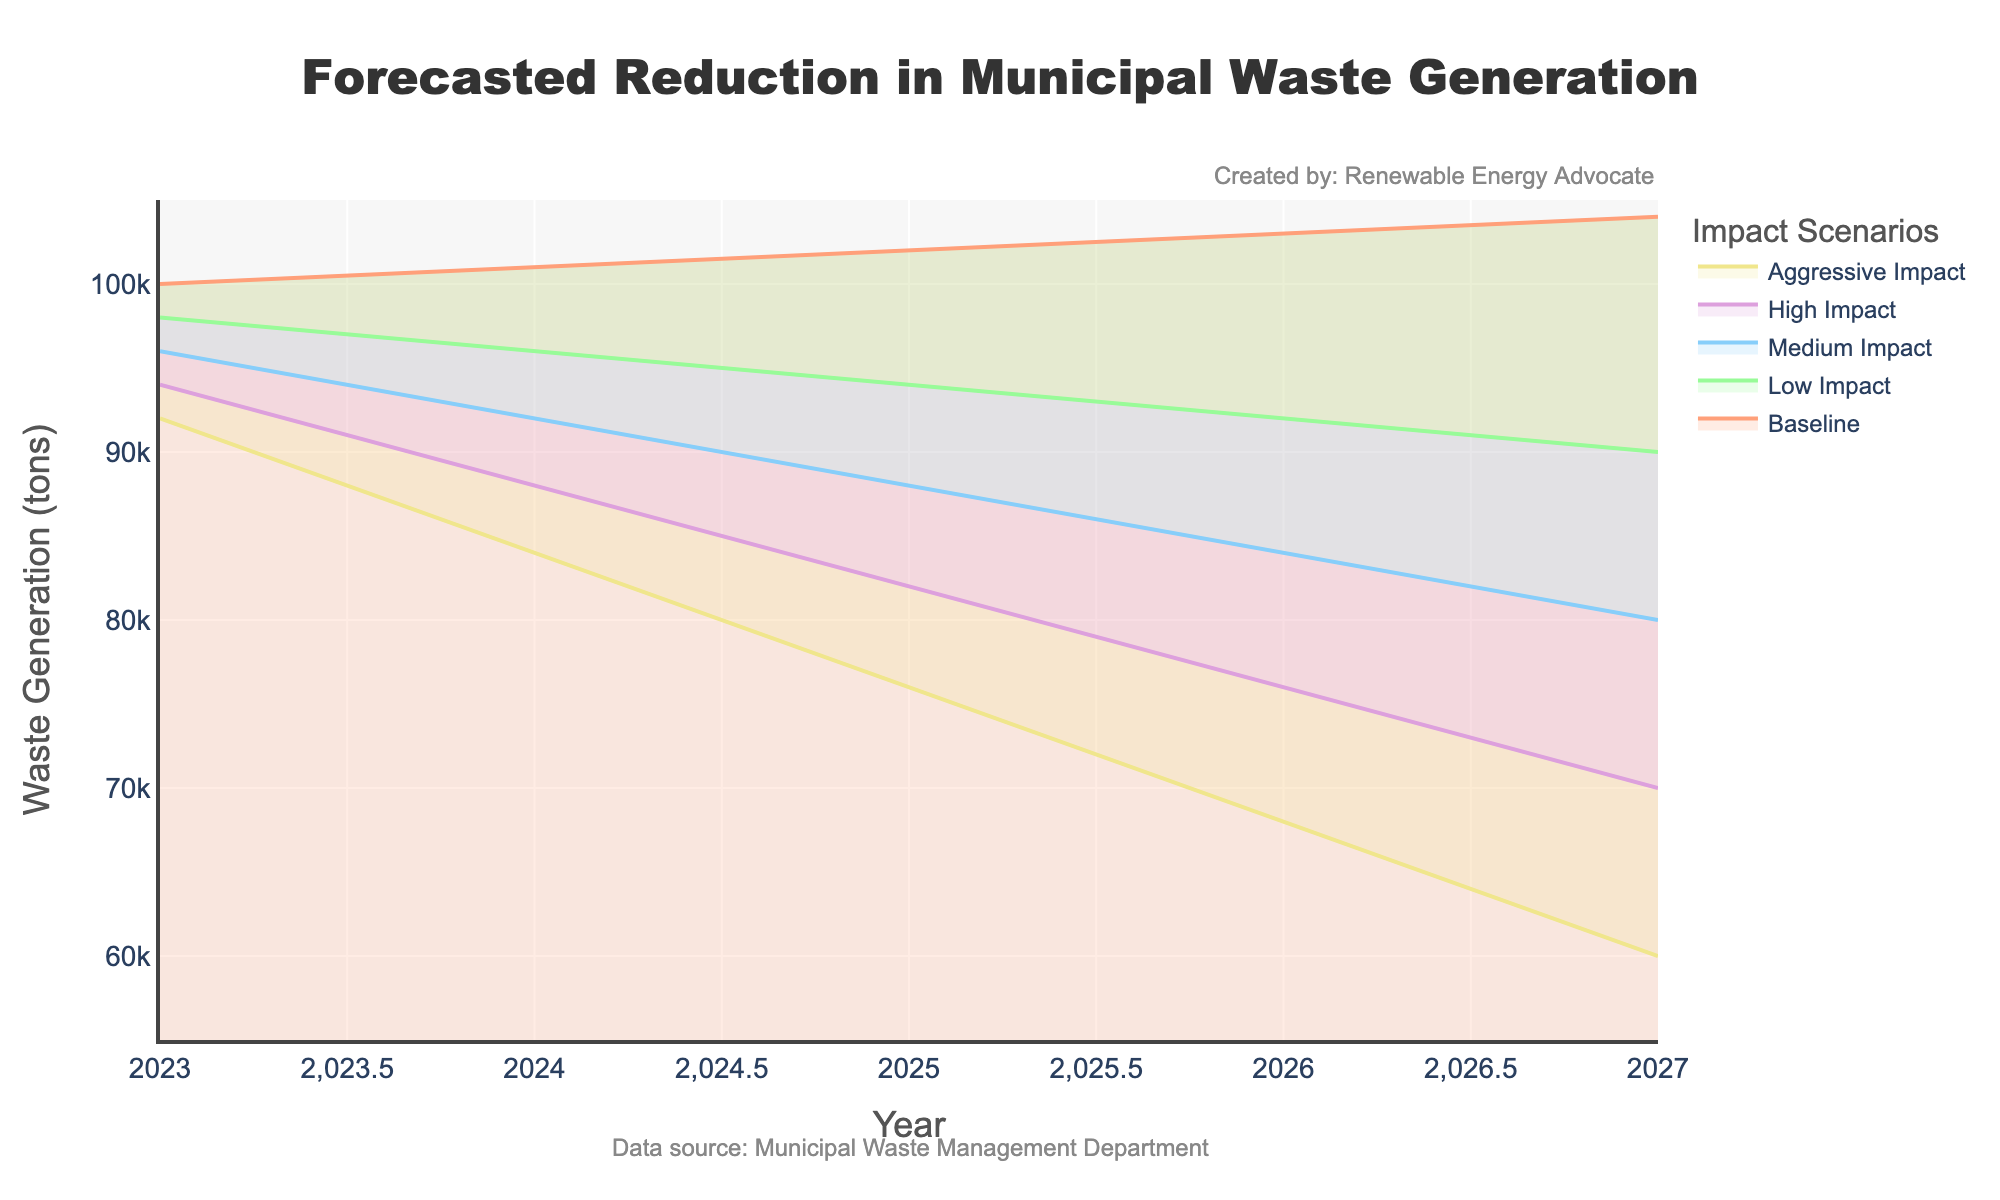What's the title of the figure? The title of the figure is the text displayed at the top, providing a quick understanding of what the figure represents.
Answer: Forecasted Reduction in Municipal Waste Generation What is the y-axis label? The y-axis label is the vertical text next to the y-axis, indicating what the y-axis represents.
Answer: Waste Generation (tons) In 2025, what's the difference in waste generated between the Baseline and Aggressive Impact scenarios? Locate the values for 2025 under the Baseline and Aggressive Impact columns. Subtract the Aggressive Impact value from the Baseline value (102000 - 76000).
Answer: 26000 tons Between 2023 and 2027, which scenario shows the most significant reduction in waste generation, and by how much? Calculate the difference between the waste generated in 2023 and 2027 for each scenario, then find which difference is the largest. Aggressive Impact shows the largest reduction. (2023: 92000, 2027: 60000; 92000 - 60000)
Answer: Aggressive Impact, 32000 tons How many impact scenarios are shown in the figure? Count the different colored bands representing the various scenarios in the figure.
Answer: 5 Which year has the highest baseline forecast for waste generation, and what is the value? Compare the baseline values across the years listed. The highest value is in 2027 (104000).
Answer: 2027, 104000 tons In 2024, which scenario forecasted the lowest waste generation, and what is the value? Look at the 2024 values for all scenarios and identify the lowest one (Aggressive Impact: 84000).
Answer: Aggressive Impact, 84000 tons What's the difference in projected waste generation between the High Impact and Medium Impact scenarios in 2026? Locate the values for 2026 under High Impact and Medium Impact. Subtract the Medium Impact value from the High Impact value (76000 - 84000).
Answer: -8000 tons What trend can you observe for the waste generation under the Baseline scenario from 2023 to 2027? Observe the values for the Baseline scenario across all years and note if they are increasing, decreasing, or stable. They consistently increase from 100000 to 104000.
Answer: Increasing By what percentage does the waste generation decrease from 2023 to 2027 under the Low Impact scenario? Calculate the percentage decrease using the values for 2023 and 2027 under the Low Impact scenario. ((98000 - 90000) / 98000) * 100.
Answer: 8.16% 